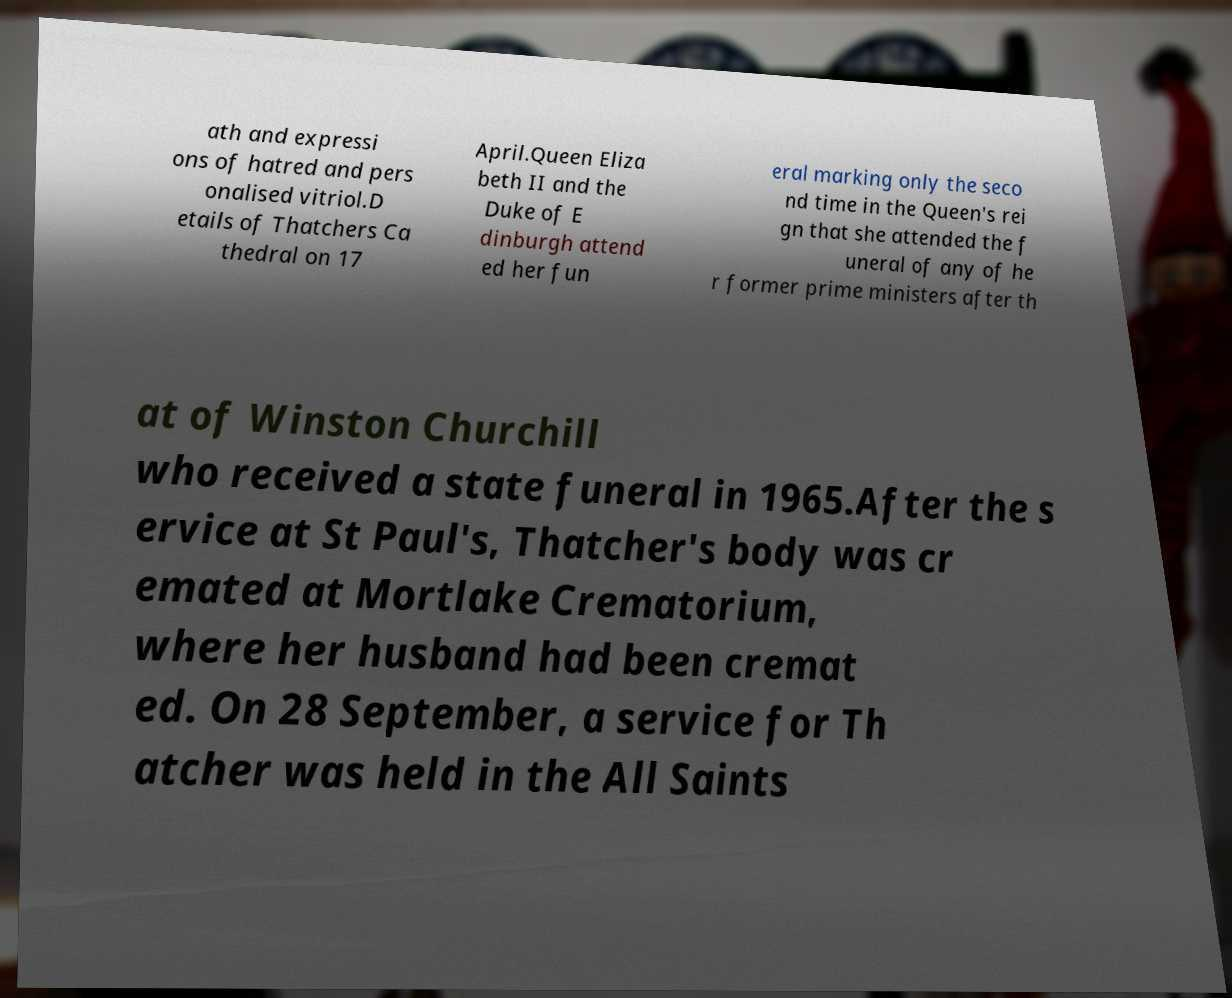Could you assist in decoding the text presented in this image and type it out clearly? ath and expressi ons of hatred and pers onalised vitriol.D etails of Thatchers Ca thedral on 17 April.Queen Eliza beth II and the Duke of E dinburgh attend ed her fun eral marking only the seco nd time in the Queen's rei gn that she attended the f uneral of any of he r former prime ministers after th at of Winston Churchill who received a state funeral in 1965.After the s ervice at St Paul's, Thatcher's body was cr emated at Mortlake Crematorium, where her husband had been cremat ed. On 28 September, a service for Th atcher was held in the All Saints 